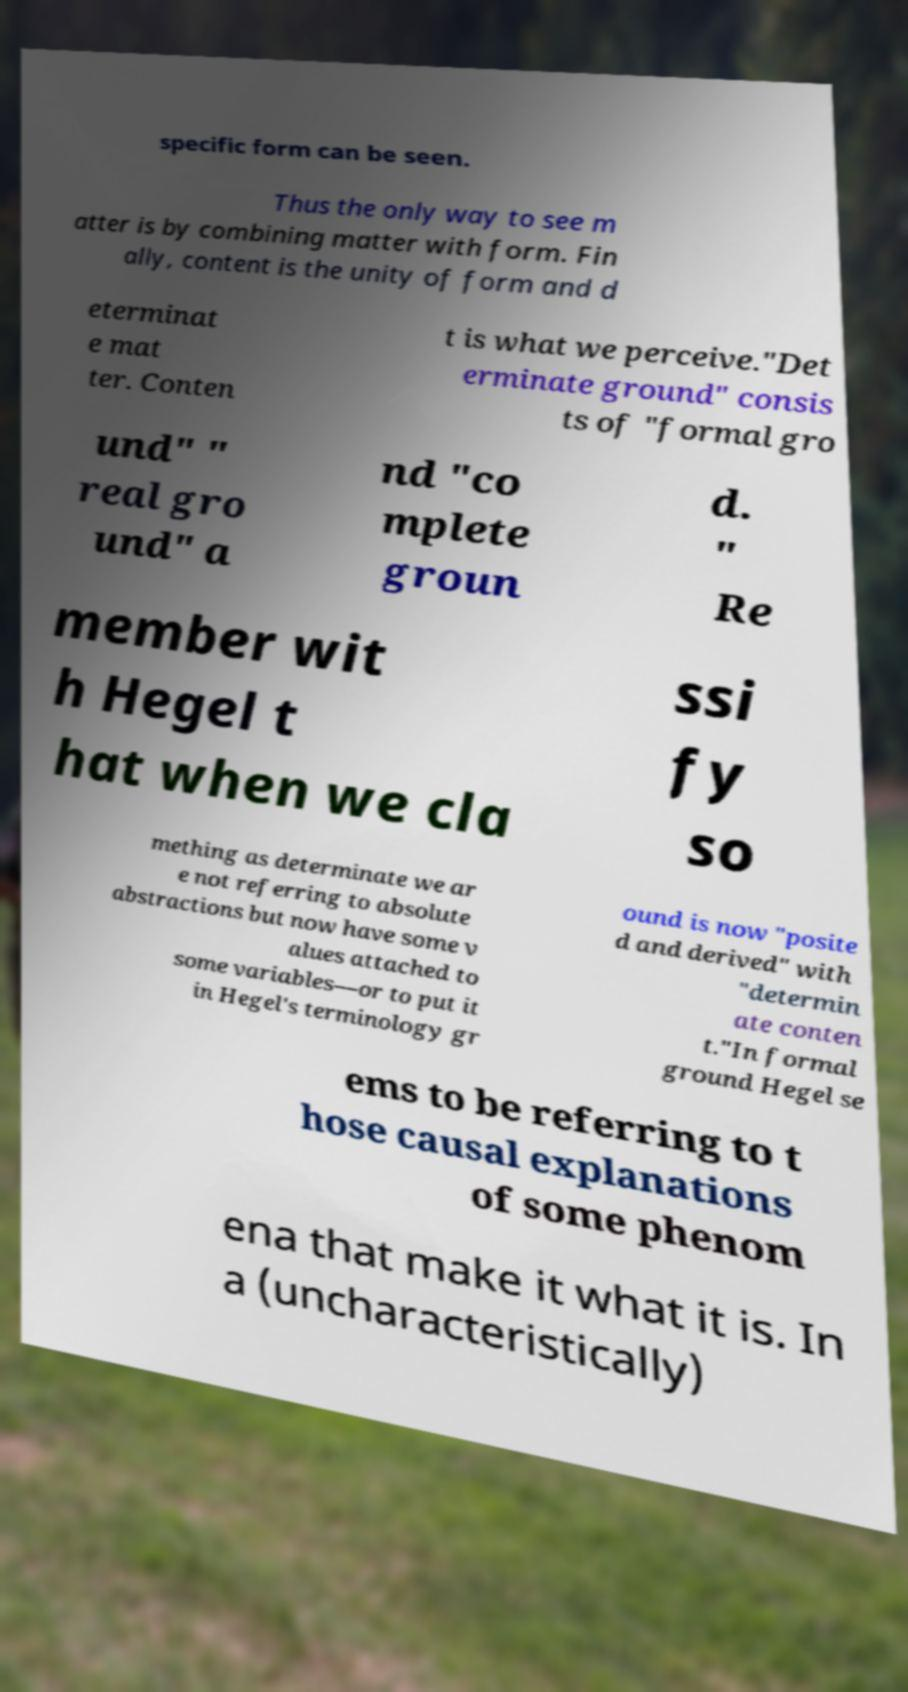There's text embedded in this image that I need extracted. Can you transcribe it verbatim? specific form can be seen. Thus the only way to see m atter is by combining matter with form. Fin ally, content is the unity of form and d eterminat e mat ter. Conten t is what we perceive."Det erminate ground" consis ts of "formal gro und" " real gro und" a nd "co mplete groun d. " Re member wit h Hegel t hat when we cla ssi fy so mething as determinate we ar e not referring to absolute abstractions but now have some v alues attached to some variables—or to put it in Hegel's terminology gr ound is now "posite d and derived" with "determin ate conten t."In formal ground Hegel se ems to be referring to t hose causal explanations of some phenom ena that make it what it is. In a (uncharacteristically) 